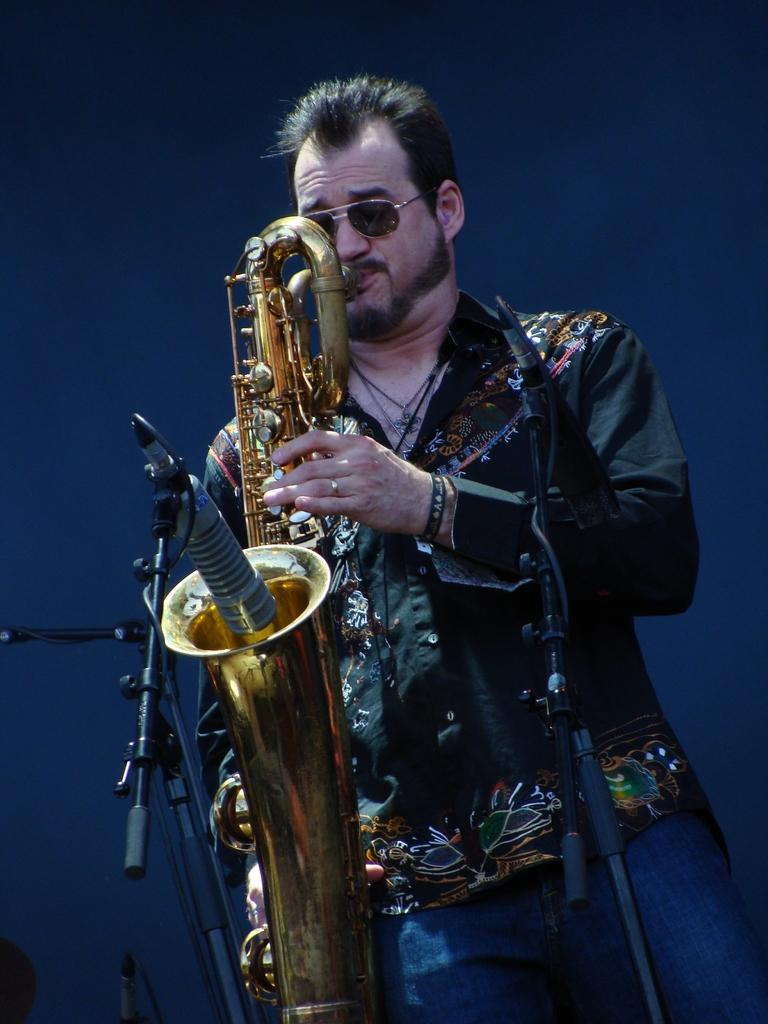What is the main subject of the image? There is a person standing in the image. What is the person doing in the image? The person is playing a musical instrument. What object is present in the image that is commonly used for amplifying sound? There is a microphone in the image. What can be said about the lighting conditions in the image? The background of the image is dark. What type of fire can be seen in the image? There is no fire present in the image. What season is depicted in the image, considering the presence of air? The image does not depict a specific season, and the presence of air is a natural and constant element in any image. 